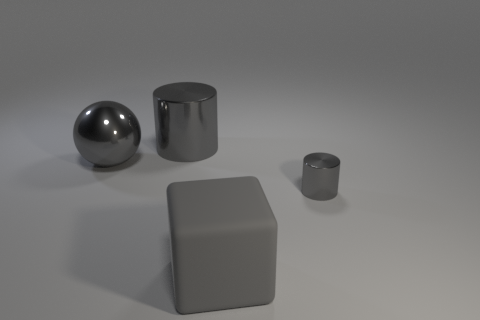Add 2 cylinders. How many objects exist? 6 Subtract all balls. How many objects are left? 3 Subtract all metal things. Subtract all small metal cylinders. How many objects are left? 0 Add 3 big gray cubes. How many big gray cubes are left? 4 Add 1 gray matte cylinders. How many gray matte cylinders exist? 1 Subtract 0 yellow cylinders. How many objects are left? 4 